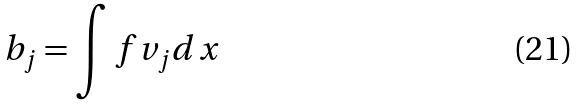Convert formula to latex. <formula><loc_0><loc_0><loc_500><loc_500>b _ { j } = \int f v _ { j } d x</formula> 